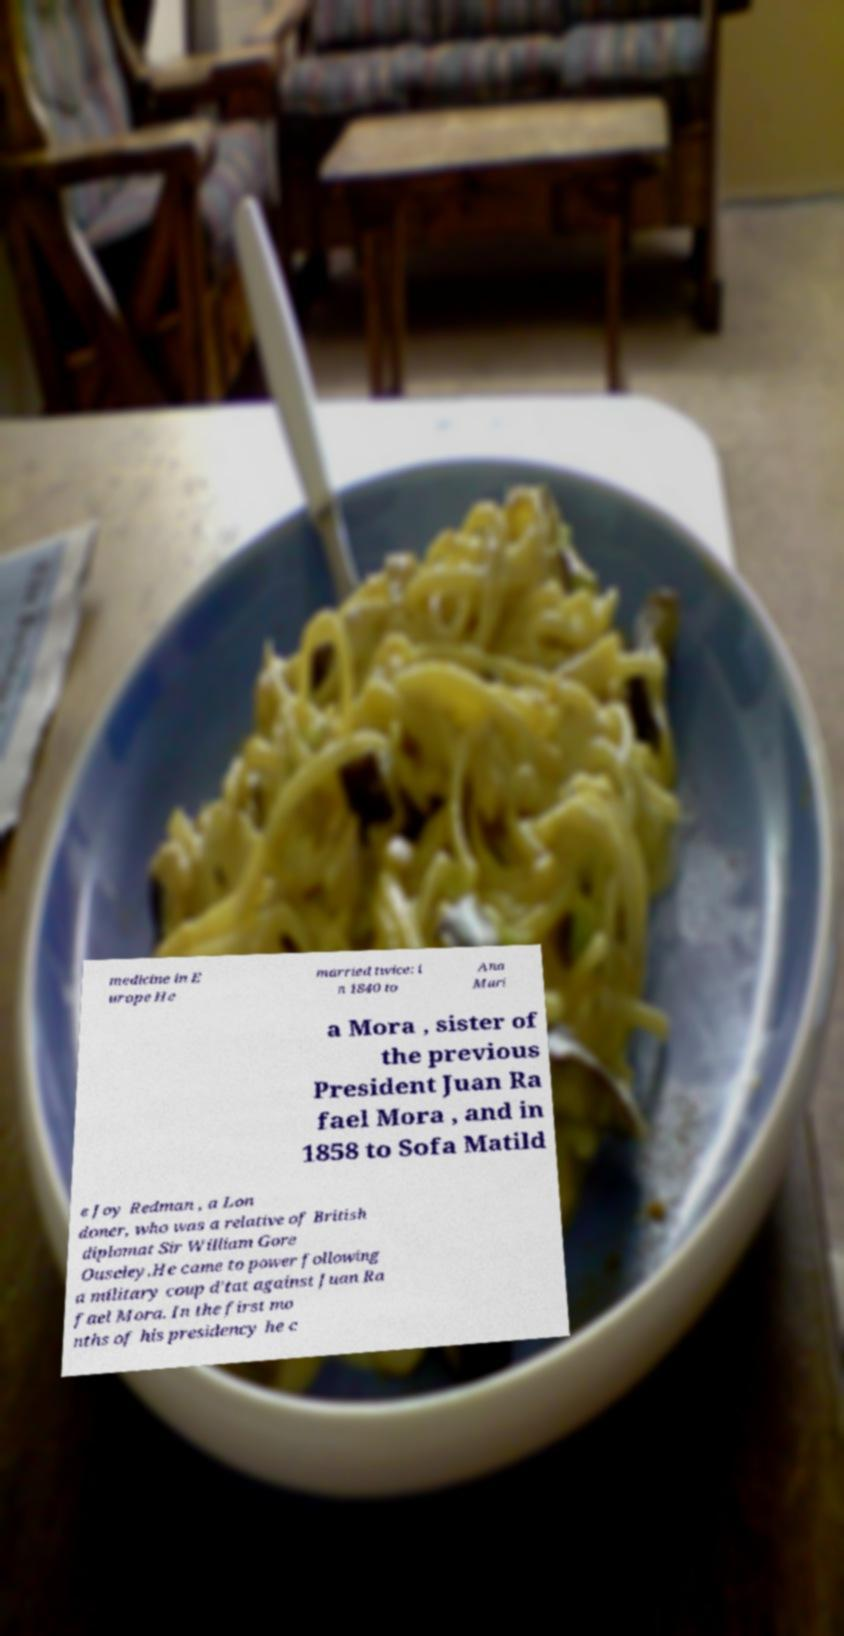There's text embedded in this image that I need extracted. Can you transcribe it verbatim? medicine in E urope He married twice: i n 1840 to Ana Mari a Mora , sister of the previous President Juan Ra fael Mora , and in 1858 to Sofa Matild e Joy Redman , a Lon doner, who was a relative of British diplomat Sir William Gore Ouseley.He came to power following a military coup d'tat against Juan Ra fael Mora. In the first mo nths of his presidency he c 